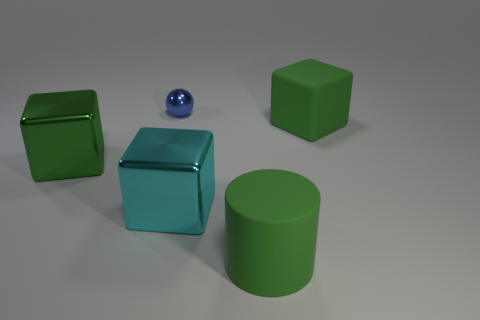Subtract all large cyan cubes. How many cubes are left? 2 Add 2 green objects. How many objects exist? 7 Subtract all cubes. How many objects are left? 2 Subtract 1 spheres. How many spheres are left? 0 Subtract all purple balls. How many green blocks are left? 2 Add 2 balls. How many balls are left? 3 Add 3 small cyan rubber things. How many small cyan rubber things exist? 3 Subtract all cyan cubes. How many cubes are left? 2 Subtract 0 purple spheres. How many objects are left? 5 Subtract all red cubes. Subtract all blue balls. How many cubes are left? 3 